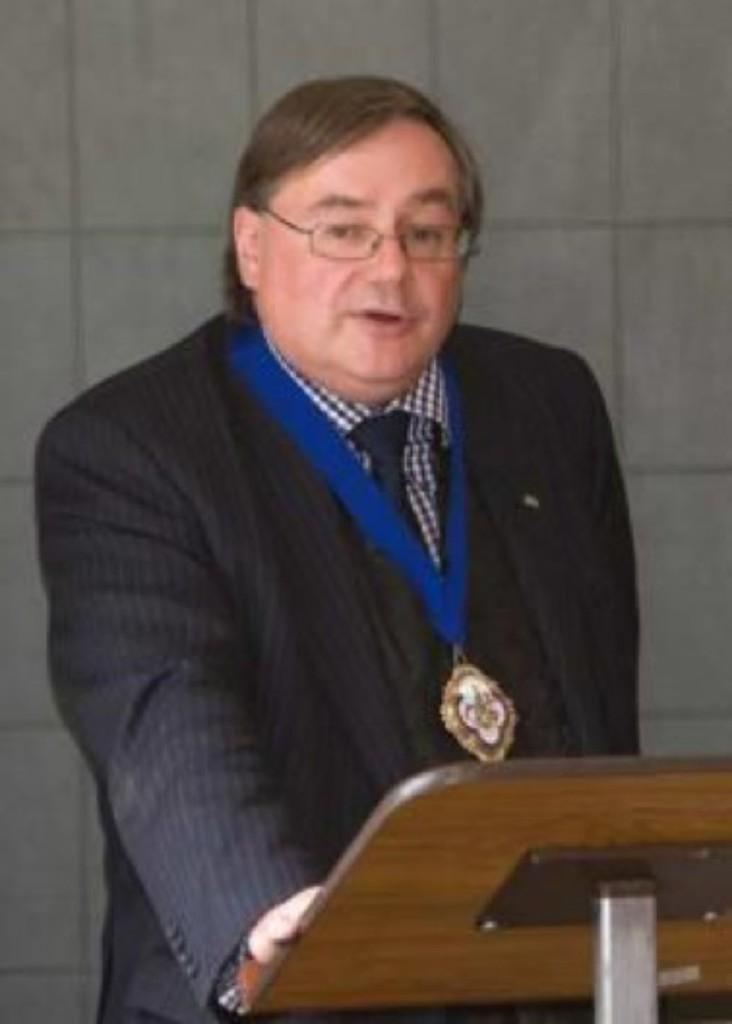What is the person in the image doing? The person is standing and talking. What is the person wearing in the image? The person is wearing a medal and glasses. What is in front of the person in the image? There is a table in front of the person. What can be seen in the background of the image? There is a wall in the background. What type of popcorn is the person eating in the image? There is no popcorn present in the image. What is the person's name in the image? The person's name is not mentioned or visible in the image. 